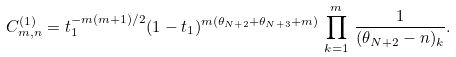<formula> <loc_0><loc_0><loc_500><loc_500>C ^ { ( 1 ) } _ { m , n } = t _ { 1 } ^ { - m ( m + 1 ) / 2 } ( 1 - t _ { 1 } ) ^ { m ( \theta _ { N + 2 } + \theta _ { N + 3 } + m ) } \, \prod _ { k = 1 } ^ { m } \, \frac { 1 } { ( \theta _ { N + 2 } - n ) _ { k } } .</formula> 